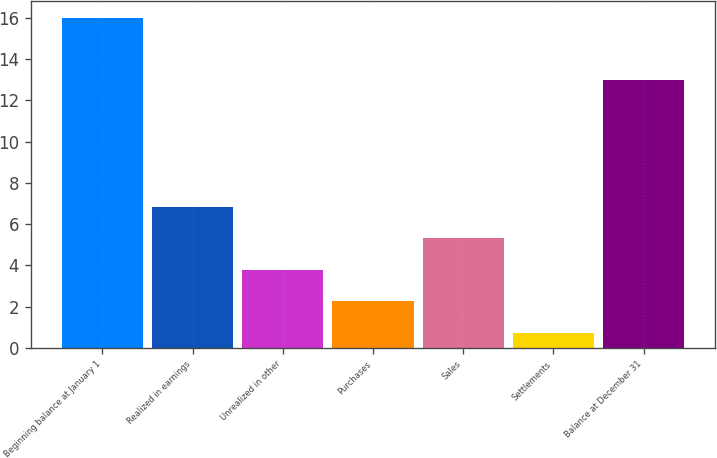<chart> <loc_0><loc_0><loc_500><loc_500><bar_chart><fcel>Beginning balance at January 1<fcel>Realized in earnings<fcel>Unrealized in other<fcel>Purchases<fcel>Sales<fcel>Settlements<fcel>Balance at December 31<nl><fcel>16<fcel>6.85<fcel>3.79<fcel>2.26<fcel>5.32<fcel>0.73<fcel>13<nl></chart> 